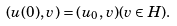Convert formula to latex. <formula><loc_0><loc_0><loc_500><loc_500>( u ( 0 ) , v ) = ( u _ { 0 } , v ) ( v \in H ) .</formula> 